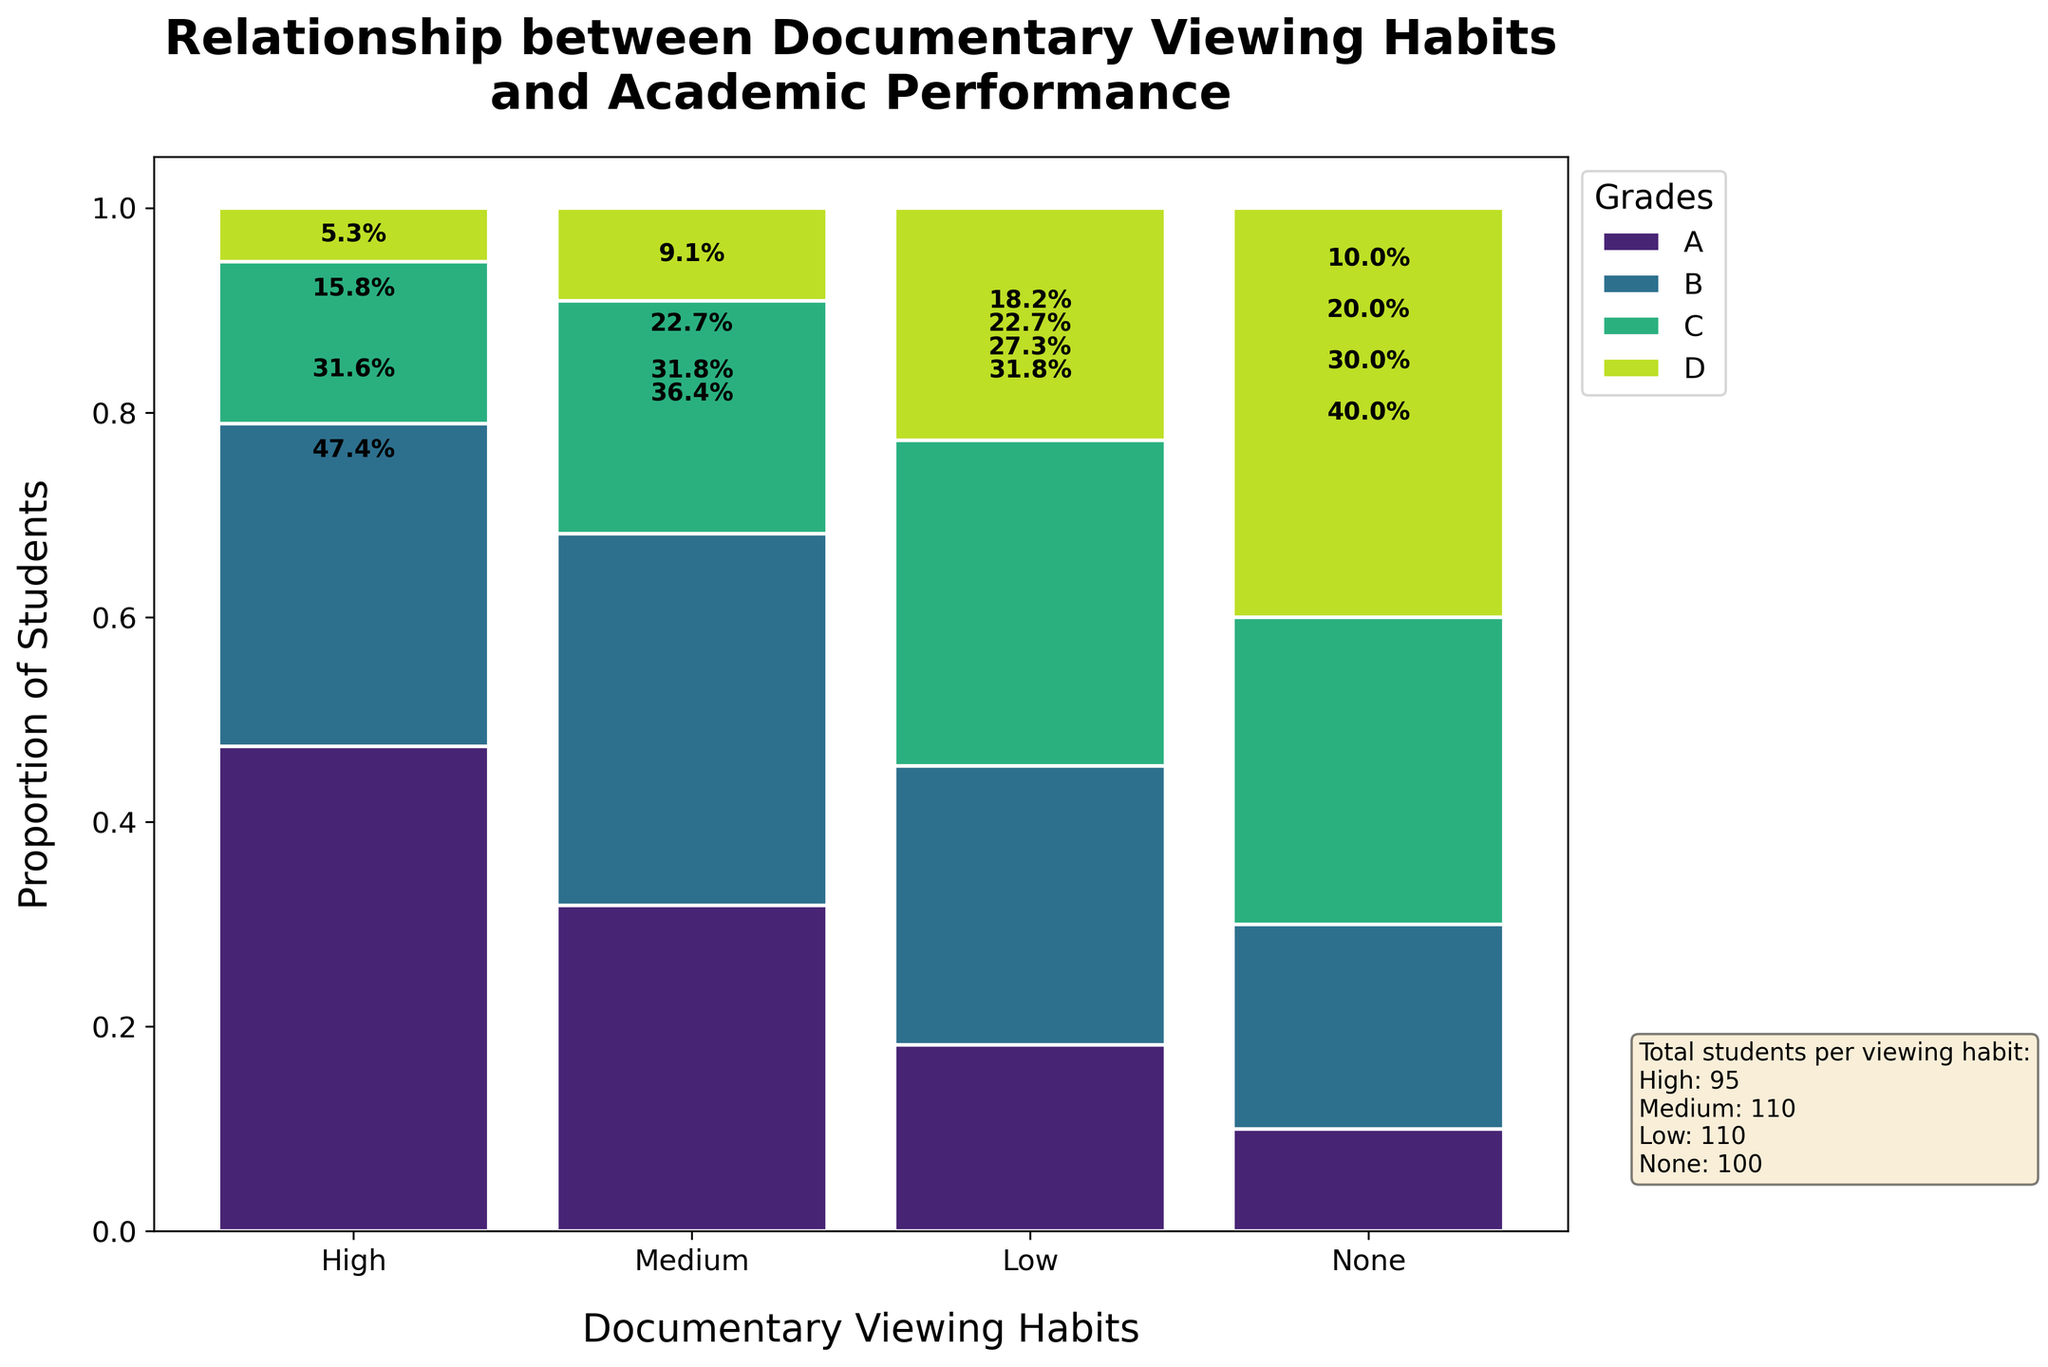What is the title of the figure? The title of the figure is usually displayed at the top. For this figure, it is "Relationship between Documentary Viewing Habits and Academic Performance."
Answer: Relationship between Documentary Viewing Habits and Academic Performance Which documentary viewing habit has the highest proportion of students with grade A? By looking at the tallest segment in the 'A' grade bar, we can see that the 'High' category has the most students with an A grade.
Answer: High How many students fall into the 'None' category across all grades? The 'None' category total is mentioned in the text box on the plot. It states "None: 100".
Answer: 100 What proportion of students with 'High' documentary viewing habits received a grade of B? From the bar representing 'High' habits, find the portion corresponding to grade B, which is approximately 30/(45+30+15+5) = 30/95 ≈ 0.316, or about 31.6%.
Answer: 31.6% Which viewing habit category has the lowest proportion of students receiving a grade D? Examine the D grade segments across all viewing habits; 'High' has the smallest segment, indicating the lowest proportion.
Answer: High Compare the proportions of students who received grade C with 'Medium' and 'Low' viewing habits. Which is greater? For 'Medium,' the proportion is approximately 25/110 ≈ 0.227, and for 'Low,' it's about 35/110 ≈ 0.318. Between these, 'Low' has a greater proportion.
Answer: Low What percent of students who have 'Low' documentary viewing habits received grades A or B combined? For 'Low,' add the proportions for grades A and B: 20/110 + 30/110 = 50/110 ≈ 45.5%.
Answer: 45.5% Which academic performance grade is the least common among students with 'None' documentary viewing habits? The smallest segment in the 'None' category bar corresponds to grade A, indicating it is the least common.
Answer: A Is there a general trend in academic performance with respect to documentary viewing habits? The plot shows a clear trend where higher viewing habits correlate with higher proportions of students receiving A and B grades, while lower viewing habits correlate with higher proportions of C and D grades.
Answer: Yes How does the proportion of students with a grade D in the 'None' category compare to those with 'Low' documentary viewing habits? Referring to the segments for grade D, 'None' has approximately 40/100 = 40%, and 'Low' has approximately 25/110 ≈ 22.7%. The proportion is higher in the 'None' category.
Answer: Higher in None 